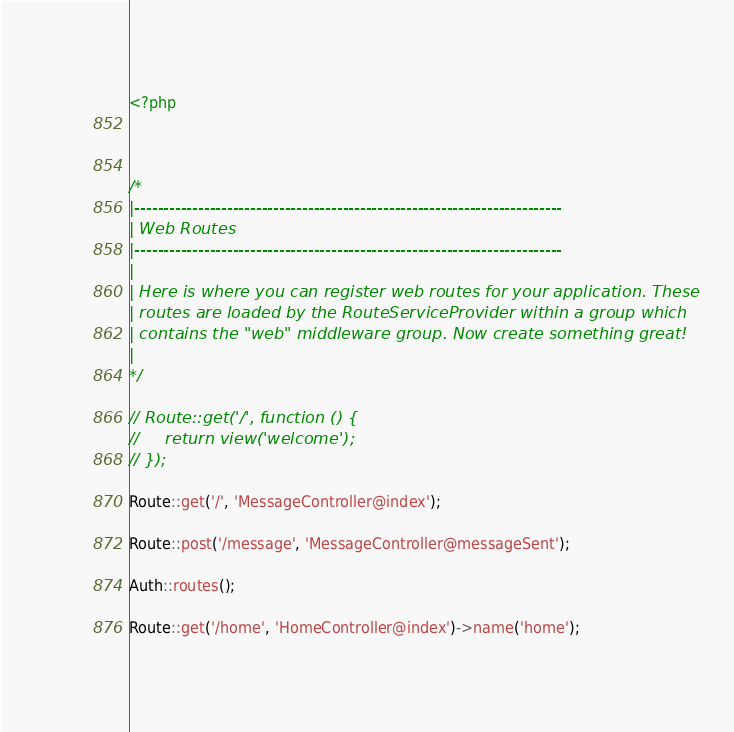Convert code to text. <code><loc_0><loc_0><loc_500><loc_500><_PHP_><?php



/*
|--------------------------------------------------------------------------
| Web Routes
|--------------------------------------------------------------------------
|
| Here is where you can register web routes for your application. These
| routes are loaded by the RouteServiceProvider within a group which
| contains the "web" middleware group. Now create something great!
|
*/

// Route::get('/', function () {
//     return view('welcome');
// });

Route::get('/', 'MessageController@index');

Route::post('/message', 'MessageController@messageSent');

Auth::routes();

Route::get('/home', 'HomeController@index')->name('home');
</code> 